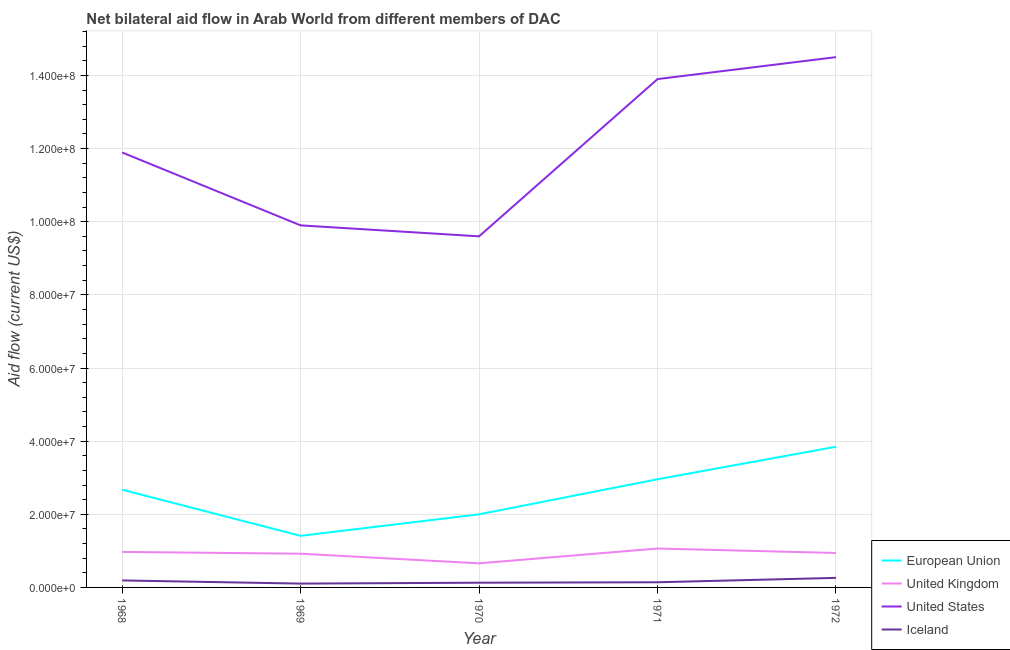How many different coloured lines are there?
Your answer should be compact. 4. What is the amount of aid given by us in 1971?
Make the answer very short. 1.39e+08. Across all years, what is the maximum amount of aid given by iceland?
Your response must be concise. 2.61e+06. Across all years, what is the minimum amount of aid given by eu?
Give a very brief answer. 1.41e+07. In which year was the amount of aid given by us maximum?
Your response must be concise. 1972. In which year was the amount of aid given by uk minimum?
Your answer should be compact. 1970. What is the total amount of aid given by iceland in the graph?
Your response must be concise. 8.27e+06. What is the difference between the amount of aid given by eu in 1971 and that in 1972?
Give a very brief answer. -8.89e+06. What is the difference between the amount of aid given by uk in 1970 and the amount of aid given by iceland in 1968?
Ensure brevity in your answer.  4.68e+06. What is the average amount of aid given by uk per year?
Your answer should be very brief. 9.12e+06. In the year 1968, what is the difference between the amount of aid given by us and amount of aid given by eu?
Your answer should be very brief. 9.22e+07. In how many years, is the amount of aid given by iceland greater than 120000000 US$?
Make the answer very short. 0. What is the ratio of the amount of aid given by us in 1969 to that in 1970?
Provide a succinct answer. 1.03. What is the difference between the highest and the lowest amount of aid given by uk?
Keep it short and to the point. 4.05e+06. Is it the case that in every year, the sum of the amount of aid given by iceland and amount of aid given by us is greater than the sum of amount of aid given by uk and amount of aid given by eu?
Your answer should be compact. Yes. Is it the case that in every year, the sum of the amount of aid given by eu and amount of aid given by uk is greater than the amount of aid given by us?
Your answer should be very brief. No. How many lines are there?
Your answer should be very brief. 4. How many years are there in the graph?
Give a very brief answer. 5. What is the difference between two consecutive major ticks on the Y-axis?
Your response must be concise. 2.00e+07. Are the values on the major ticks of Y-axis written in scientific E-notation?
Your answer should be very brief. Yes. Does the graph contain any zero values?
Ensure brevity in your answer.  No. How many legend labels are there?
Your answer should be very brief. 4. What is the title of the graph?
Your answer should be compact. Net bilateral aid flow in Arab World from different members of DAC. What is the label or title of the X-axis?
Give a very brief answer. Year. What is the Aid flow (current US$) of European Union in 1968?
Provide a short and direct response. 2.67e+07. What is the Aid flow (current US$) of United Kingdom in 1968?
Give a very brief answer. 9.71e+06. What is the Aid flow (current US$) of United States in 1968?
Offer a very short reply. 1.19e+08. What is the Aid flow (current US$) in Iceland in 1968?
Offer a very short reply. 1.91e+06. What is the Aid flow (current US$) in European Union in 1969?
Your answer should be very brief. 1.41e+07. What is the Aid flow (current US$) in United Kingdom in 1969?
Give a very brief answer. 9.22e+06. What is the Aid flow (current US$) of United States in 1969?
Keep it short and to the point. 9.90e+07. What is the Aid flow (current US$) in Iceland in 1969?
Offer a terse response. 1.05e+06. What is the Aid flow (current US$) in European Union in 1970?
Ensure brevity in your answer.  2.00e+07. What is the Aid flow (current US$) in United Kingdom in 1970?
Provide a short and direct response. 6.59e+06. What is the Aid flow (current US$) in United States in 1970?
Your answer should be compact. 9.60e+07. What is the Aid flow (current US$) of Iceland in 1970?
Make the answer very short. 1.29e+06. What is the Aid flow (current US$) in European Union in 1971?
Provide a short and direct response. 2.96e+07. What is the Aid flow (current US$) in United Kingdom in 1971?
Your response must be concise. 1.06e+07. What is the Aid flow (current US$) in United States in 1971?
Ensure brevity in your answer.  1.39e+08. What is the Aid flow (current US$) in Iceland in 1971?
Ensure brevity in your answer.  1.41e+06. What is the Aid flow (current US$) of European Union in 1972?
Offer a terse response. 3.85e+07. What is the Aid flow (current US$) of United Kingdom in 1972?
Your answer should be compact. 9.42e+06. What is the Aid flow (current US$) in United States in 1972?
Offer a terse response. 1.45e+08. What is the Aid flow (current US$) of Iceland in 1972?
Your answer should be compact. 2.61e+06. Across all years, what is the maximum Aid flow (current US$) of European Union?
Your answer should be very brief. 3.85e+07. Across all years, what is the maximum Aid flow (current US$) of United Kingdom?
Provide a succinct answer. 1.06e+07. Across all years, what is the maximum Aid flow (current US$) in United States?
Your answer should be very brief. 1.45e+08. Across all years, what is the maximum Aid flow (current US$) of Iceland?
Your answer should be compact. 2.61e+06. Across all years, what is the minimum Aid flow (current US$) of European Union?
Give a very brief answer. 1.41e+07. Across all years, what is the minimum Aid flow (current US$) of United Kingdom?
Ensure brevity in your answer.  6.59e+06. Across all years, what is the minimum Aid flow (current US$) in United States?
Your response must be concise. 9.60e+07. Across all years, what is the minimum Aid flow (current US$) of Iceland?
Make the answer very short. 1.05e+06. What is the total Aid flow (current US$) of European Union in the graph?
Offer a terse response. 1.29e+08. What is the total Aid flow (current US$) of United Kingdom in the graph?
Your answer should be very brief. 4.56e+07. What is the total Aid flow (current US$) of United States in the graph?
Ensure brevity in your answer.  5.98e+08. What is the total Aid flow (current US$) of Iceland in the graph?
Keep it short and to the point. 8.27e+06. What is the difference between the Aid flow (current US$) of European Union in 1968 and that in 1969?
Your answer should be very brief. 1.26e+07. What is the difference between the Aid flow (current US$) in United Kingdom in 1968 and that in 1969?
Provide a succinct answer. 4.90e+05. What is the difference between the Aid flow (current US$) of United States in 1968 and that in 1969?
Provide a short and direct response. 1.99e+07. What is the difference between the Aid flow (current US$) of Iceland in 1968 and that in 1969?
Ensure brevity in your answer.  8.60e+05. What is the difference between the Aid flow (current US$) in European Union in 1968 and that in 1970?
Make the answer very short. 6.73e+06. What is the difference between the Aid flow (current US$) in United Kingdom in 1968 and that in 1970?
Give a very brief answer. 3.12e+06. What is the difference between the Aid flow (current US$) in United States in 1968 and that in 1970?
Keep it short and to the point. 2.29e+07. What is the difference between the Aid flow (current US$) of Iceland in 1968 and that in 1970?
Your answer should be very brief. 6.20e+05. What is the difference between the Aid flow (current US$) in European Union in 1968 and that in 1971?
Offer a very short reply. -2.86e+06. What is the difference between the Aid flow (current US$) in United Kingdom in 1968 and that in 1971?
Provide a succinct answer. -9.30e+05. What is the difference between the Aid flow (current US$) in United States in 1968 and that in 1971?
Ensure brevity in your answer.  -2.01e+07. What is the difference between the Aid flow (current US$) in Iceland in 1968 and that in 1971?
Provide a short and direct response. 5.00e+05. What is the difference between the Aid flow (current US$) in European Union in 1968 and that in 1972?
Provide a succinct answer. -1.18e+07. What is the difference between the Aid flow (current US$) in United Kingdom in 1968 and that in 1972?
Provide a short and direct response. 2.90e+05. What is the difference between the Aid flow (current US$) in United States in 1968 and that in 1972?
Give a very brief answer. -2.61e+07. What is the difference between the Aid flow (current US$) of Iceland in 1968 and that in 1972?
Provide a short and direct response. -7.00e+05. What is the difference between the Aid flow (current US$) of European Union in 1969 and that in 1970?
Your response must be concise. -5.88e+06. What is the difference between the Aid flow (current US$) of United Kingdom in 1969 and that in 1970?
Ensure brevity in your answer.  2.63e+06. What is the difference between the Aid flow (current US$) of United States in 1969 and that in 1970?
Ensure brevity in your answer.  3.00e+06. What is the difference between the Aid flow (current US$) in Iceland in 1969 and that in 1970?
Your answer should be very brief. -2.40e+05. What is the difference between the Aid flow (current US$) of European Union in 1969 and that in 1971?
Offer a very short reply. -1.55e+07. What is the difference between the Aid flow (current US$) in United Kingdom in 1969 and that in 1971?
Keep it short and to the point. -1.42e+06. What is the difference between the Aid flow (current US$) of United States in 1969 and that in 1971?
Offer a terse response. -4.00e+07. What is the difference between the Aid flow (current US$) in Iceland in 1969 and that in 1971?
Provide a succinct answer. -3.60e+05. What is the difference between the Aid flow (current US$) in European Union in 1969 and that in 1972?
Keep it short and to the point. -2.44e+07. What is the difference between the Aid flow (current US$) in United Kingdom in 1969 and that in 1972?
Offer a very short reply. -2.00e+05. What is the difference between the Aid flow (current US$) of United States in 1969 and that in 1972?
Make the answer very short. -4.60e+07. What is the difference between the Aid flow (current US$) of Iceland in 1969 and that in 1972?
Provide a short and direct response. -1.56e+06. What is the difference between the Aid flow (current US$) in European Union in 1970 and that in 1971?
Offer a very short reply. -9.59e+06. What is the difference between the Aid flow (current US$) of United Kingdom in 1970 and that in 1971?
Make the answer very short. -4.05e+06. What is the difference between the Aid flow (current US$) in United States in 1970 and that in 1971?
Provide a succinct answer. -4.30e+07. What is the difference between the Aid flow (current US$) in Iceland in 1970 and that in 1971?
Your answer should be compact. -1.20e+05. What is the difference between the Aid flow (current US$) of European Union in 1970 and that in 1972?
Keep it short and to the point. -1.85e+07. What is the difference between the Aid flow (current US$) in United Kingdom in 1970 and that in 1972?
Ensure brevity in your answer.  -2.83e+06. What is the difference between the Aid flow (current US$) of United States in 1970 and that in 1972?
Offer a very short reply. -4.90e+07. What is the difference between the Aid flow (current US$) in Iceland in 1970 and that in 1972?
Keep it short and to the point. -1.32e+06. What is the difference between the Aid flow (current US$) of European Union in 1971 and that in 1972?
Provide a short and direct response. -8.89e+06. What is the difference between the Aid flow (current US$) of United Kingdom in 1971 and that in 1972?
Provide a succinct answer. 1.22e+06. What is the difference between the Aid flow (current US$) in United States in 1971 and that in 1972?
Your response must be concise. -6.00e+06. What is the difference between the Aid flow (current US$) in Iceland in 1971 and that in 1972?
Provide a short and direct response. -1.20e+06. What is the difference between the Aid flow (current US$) in European Union in 1968 and the Aid flow (current US$) in United Kingdom in 1969?
Your answer should be compact. 1.75e+07. What is the difference between the Aid flow (current US$) in European Union in 1968 and the Aid flow (current US$) in United States in 1969?
Offer a very short reply. -7.23e+07. What is the difference between the Aid flow (current US$) of European Union in 1968 and the Aid flow (current US$) of Iceland in 1969?
Your answer should be very brief. 2.57e+07. What is the difference between the Aid flow (current US$) of United Kingdom in 1968 and the Aid flow (current US$) of United States in 1969?
Keep it short and to the point. -8.93e+07. What is the difference between the Aid flow (current US$) of United Kingdom in 1968 and the Aid flow (current US$) of Iceland in 1969?
Keep it short and to the point. 8.66e+06. What is the difference between the Aid flow (current US$) in United States in 1968 and the Aid flow (current US$) in Iceland in 1969?
Make the answer very short. 1.18e+08. What is the difference between the Aid flow (current US$) in European Union in 1968 and the Aid flow (current US$) in United Kingdom in 1970?
Provide a succinct answer. 2.01e+07. What is the difference between the Aid flow (current US$) of European Union in 1968 and the Aid flow (current US$) of United States in 1970?
Your answer should be compact. -6.93e+07. What is the difference between the Aid flow (current US$) in European Union in 1968 and the Aid flow (current US$) in Iceland in 1970?
Ensure brevity in your answer.  2.54e+07. What is the difference between the Aid flow (current US$) in United Kingdom in 1968 and the Aid flow (current US$) in United States in 1970?
Make the answer very short. -8.63e+07. What is the difference between the Aid flow (current US$) in United Kingdom in 1968 and the Aid flow (current US$) in Iceland in 1970?
Offer a very short reply. 8.42e+06. What is the difference between the Aid flow (current US$) of United States in 1968 and the Aid flow (current US$) of Iceland in 1970?
Make the answer very short. 1.18e+08. What is the difference between the Aid flow (current US$) of European Union in 1968 and the Aid flow (current US$) of United Kingdom in 1971?
Keep it short and to the point. 1.61e+07. What is the difference between the Aid flow (current US$) in European Union in 1968 and the Aid flow (current US$) in United States in 1971?
Your answer should be very brief. -1.12e+08. What is the difference between the Aid flow (current US$) in European Union in 1968 and the Aid flow (current US$) in Iceland in 1971?
Ensure brevity in your answer.  2.53e+07. What is the difference between the Aid flow (current US$) of United Kingdom in 1968 and the Aid flow (current US$) of United States in 1971?
Provide a succinct answer. -1.29e+08. What is the difference between the Aid flow (current US$) in United Kingdom in 1968 and the Aid flow (current US$) in Iceland in 1971?
Offer a terse response. 8.30e+06. What is the difference between the Aid flow (current US$) in United States in 1968 and the Aid flow (current US$) in Iceland in 1971?
Your answer should be very brief. 1.18e+08. What is the difference between the Aid flow (current US$) in European Union in 1968 and the Aid flow (current US$) in United Kingdom in 1972?
Offer a terse response. 1.73e+07. What is the difference between the Aid flow (current US$) in European Union in 1968 and the Aid flow (current US$) in United States in 1972?
Offer a terse response. -1.18e+08. What is the difference between the Aid flow (current US$) of European Union in 1968 and the Aid flow (current US$) of Iceland in 1972?
Ensure brevity in your answer.  2.41e+07. What is the difference between the Aid flow (current US$) of United Kingdom in 1968 and the Aid flow (current US$) of United States in 1972?
Provide a succinct answer. -1.35e+08. What is the difference between the Aid flow (current US$) in United Kingdom in 1968 and the Aid flow (current US$) in Iceland in 1972?
Offer a terse response. 7.10e+06. What is the difference between the Aid flow (current US$) in United States in 1968 and the Aid flow (current US$) in Iceland in 1972?
Give a very brief answer. 1.16e+08. What is the difference between the Aid flow (current US$) in European Union in 1969 and the Aid flow (current US$) in United Kingdom in 1970?
Ensure brevity in your answer.  7.52e+06. What is the difference between the Aid flow (current US$) in European Union in 1969 and the Aid flow (current US$) in United States in 1970?
Keep it short and to the point. -8.19e+07. What is the difference between the Aid flow (current US$) of European Union in 1969 and the Aid flow (current US$) of Iceland in 1970?
Your answer should be very brief. 1.28e+07. What is the difference between the Aid flow (current US$) in United Kingdom in 1969 and the Aid flow (current US$) in United States in 1970?
Provide a succinct answer. -8.68e+07. What is the difference between the Aid flow (current US$) of United Kingdom in 1969 and the Aid flow (current US$) of Iceland in 1970?
Your answer should be compact. 7.93e+06. What is the difference between the Aid flow (current US$) of United States in 1969 and the Aid flow (current US$) of Iceland in 1970?
Keep it short and to the point. 9.77e+07. What is the difference between the Aid flow (current US$) of European Union in 1969 and the Aid flow (current US$) of United Kingdom in 1971?
Your answer should be very brief. 3.47e+06. What is the difference between the Aid flow (current US$) in European Union in 1969 and the Aid flow (current US$) in United States in 1971?
Make the answer very short. -1.25e+08. What is the difference between the Aid flow (current US$) of European Union in 1969 and the Aid flow (current US$) of Iceland in 1971?
Your answer should be compact. 1.27e+07. What is the difference between the Aid flow (current US$) of United Kingdom in 1969 and the Aid flow (current US$) of United States in 1971?
Provide a succinct answer. -1.30e+08. What is the difference between the Aid flow (current US$) in United Kingdom in 1969 and the Aid flow (current US$) in Iceland in 1971?
Offer a terse response. 7.81e+06. What is the difference between the Aid flow (current US$) in United States in 1969 and the Aid flow (current US$) in Iceland in 1971?
Provide a short and direct response. 9.76e+07. What is the difference between the Aid flow (current US$) in European Union in 1969 and the Aid flow (current US$) in United Kingdom in 1972?
Make the answer very short. 4.69e+06. What is the difference between the Aid flow (current US$) of European Union in 1969 and the Aid flow (current US$) of United States in 1972?
Keep it short and to the point. -1.31e+08. What is the difference between the Aid flow (current US$) of European Union in 1969 and the Aid flow (current US$) of Iceland in 1972?
Your answer should be compact. 1.15e+07. What is the difference between the Aid flow (current US$) in United Kingdom in 1969 and the Aid flow (current US$) in United States in 1972?
Keep it short and to the point. -1.36e+08. What is the difference between the Aid flow (current US$) in United Kingdom in 1969 and the Aid flow (current US$) in Iceland in 1972?
Provide a succinct answer. 6.61e+06. What is the difference between the Aid flow (current US$) of United States in 1969 and the Aid flow (current US$) of Iceland in 1972?
Ensure brevity in your answer.  9.64e+07. What is the difference between the Aid flow (current US$) of European Union in 1970 and the Aid flow (current US$) of United Kingdom in 1971?
Ensure brevity in your answer.  9.35e+06. What is the difference between the Aid flow (current US$) of European Union in 1970 and the Aid flow (current US$) of United States in 1971?
Your answer should be very brief. -1.19e+08. What is the difference between the Aid flow (current US$) of European Union in 1970 and the Aid flow (current US$) of Iceland in 1971?
Ensure brevity in your answer.  1.86e+07. What is the difference between the Aid flow (current US$) of United Kingdom in 1970 and the Aid flow (current US$) of United States in 1971?
Give a very brief answer. -1.32e+08. What is the difference between the Aid flow (current US$) in United Kingdom in 1970 and the Aid flow (current US$) in Iceland in 1971?
Your answer should be compact. 5.18e+06. What is the difference between the Aid flow (current US$) in United States in 1970 and the Aid flow (current US$) in Iceland in 1971?
Give a very brief answer. 9.46e+07. What is the difference between the Aid flow (current US$) in European Union in 1970 and the Aid flow (current US$) in United Kingdom in 1972?
Your answer should be compact. 1.06e+07. What is the difference between the Aid flow (current US$) of European Union in 1970 and the Aid flow (current US$) of United States in 1972?
Provide a short and direct response. -1.25e+08. What is the difference between the Aid flow (current US$) of European Union in 1970 and the Aid flow (current US$) of Iceland in 1972?
Ensure brevity in your answer.  1.74e+07. What is the difference between the Aid flow (current US$) of United Kingdom in 1970 and the Aid flow (current US$) of United States in 1972?
Provide a short and direct response. -1.38e+08. What is the difference between the Aid flow (current US$) of United Kingdom in 1970 and the Aid flow (current US$) of Iceland in 1972?
Provide a short and direct response. 3.98e+06. What is the difference between the Aid flow (current US$) of United States in 1970 and the Aid flow (current US$) of Iceland in 1972?
Ensure brevity in your answer.  9.34e+07. What is the difference between the Aid flow (current US$) in European Union in 1971 and the Aid flow (current US$) in United Kingdom in 1972?
Your answer should be very brief. 2.02e+07. What is the difference between the Aid flow (current US$) of European Union in 1971 and the Aid flow (current US$) of United States in 1972?
Offer a terse response. -1.15e+08. What is the difference between the Aid flow (current US$) in European Union in 1971 and the Aid flow (current US$) in Iceland in 1972?
Offer a very short reply. 2.70e+07. What is the difference between the Aid flow (current US$) of United Kingdom in 1971 and the Aid flow (current US$) of United States in 1972?
Your answer should be very brief. -1.34e+08. What is the difference between the Aid flow (current US$) in United Kingdom in 1971 and the Aid flow (current US$) in Iceland in 1972?
Provide a succinct answer. 8.03e+06. What is the difference between the Aid flow (current US$) of United States in 1971 and the Aid flow (current US$) of Iceland in 1972?
Offer a terse response. 1.36e+08. What is the average Aid flow (current US$) of European Union per year?
Provide a short and direct response. 2.58e+07. What is the average Aid flow (current US$) in United Kingdom per year?
Provide a succinct answer. 9.12e+06. What is the average Aid flow (current US$) in United States per year?
Keep it short and to the point. 1.20e+08. What is the average Aid flow (current US$) in Iceland per year?
Offer a terse response. 1.65e+06. In the year 1968, what is the difference between the Aid flow (current US$) of European Union and Aid flow (current US$) of United Kingdom?
Keep it short and to the point. 1.70e+07. In the year 1968, what is the difference between the Aid flow (current US$) of European Union and Aid flow (current US$) of United States?
Make the answer very short. -9.22e+07. In the year 1968, what is the difference between the Aid flow (current US$) of European Union and Aid flow (current US$) of Iceland?
Provide a short and direct response. 2.48e+07. In the year 1968, what is the difference between the Aid flow (current US$) of United Kingdom and Aid flow (current US$) of United States?
Offer a very short reply. -1.09e+08. In the year 1968, what is the difference between the Aid flow (current US$) of United Kingdom and Aid flow (current US$) of Iceland?
Make the answer very short. 7.80e+06. In the year 1968, what is the difference between the Aid flow (current US$) of United States and Aid flow (current US$) of Iceland?
Your answer should be compact. 1.17e+08. In the year 1969, what is the difference between the Aid flow (current US$) in European Union and Aid flow (current US$) in United Kingdom?
Keep it short and to the point. 4.89e+06. In the year 1969, what is the difference between the Aid flow (current US$) in European Union and Aid flow (current US$) in United States?
Provide a succinct answer. -8.49e+07. In the year 1969, what is the difference between the Aid flow (current US$) in European Union and Aid flow (current US$) in Iceland?
Provide a succinct answer. 1.31e+07. In the year 1969, what is the difference between the Aid flow (current US$) in United Kingdom and Aid flow (current US$) in United States?
Give a very brief answer. -8.98e+07. In the year 1969, what is the difference between the Aid flow (current US$) of United Kingdom and Aid flow (current US$) of Iceland?
Your answer should be compact. 8.17e+06. In the year 1969, what is the difference between the Aid flow (current US$) of United States and Aid flow (current US$) of Iceland?
Make the answer very short. 9.80e+07. In the year 1970, what is the difference between the Aid flow (current US$) of European Union and Aid flow (current US$) of United Kingdom?
Keep it short and to the point. 1.34e+07. In the year 1970, what is the difference between the Aid flow (current US$) in European Union and Aid flow (current US$) in United States?
Provide a short and direct response. -7.60e+07. In the year 1970, what is the difference between the Aid flow (current US$) of European Union and Aid flow (current US$) of Iceland?
Your answer should be compact. 1.87e+07. In the year 1970, what is the difference between the Aid flow (current US$) of United Kingdom and Aid flow (current US$) of United States?
Provide a short and direct response. -8.94e+07. In the year 1970, what is the difference between the Aid flow (current US$) of United Kingdom and Aid flow (current US$) of Iceland?
Provide a short and direct response. 5.30e+06. In the year 1970, what is the difference between the Aid flow (current US$) in United States and Aid flow (current US$) in Iceland?
Provide a short and direct response. 9.47e+07. In the year 1971, what is the difference between the Aid flow (current US$) of European Union and Aid flow (current US$) of United Kingdom?
Keep it short and to the point. 1.89e+07. In the year 1971, what is the difference between the Aid flow (current US$) of European Union and Aid flow (current US$) of United States?
Offer a terse response. -1.09e+08. In the year 1971, what is the difference between the Aid flow (current US$) of European Union and Aid flow (current US$) of Iceland?
Your answer should be very brief. 2.82e+07. In the year 1971, what is the difference between the Aid flow (current US$) in United Kingdom and Aid flow (current US$) in United States?
Your answer should be very brief. -1.28e+08. In the year 1971, what is the difference between the Aid flow (current US$) of United Kingdom and Aid flow (current US$) of Iceland?
Keep it short and to the point. 9.23e+06. In the year 1971, what is the difference between the Aid flow (current US$) of United States and Aid flow (current US$) of Iceland?
Your answer should be compact. 1.38e+08. In the year 1972, what is the difference between the Aid flow (current US$) in European Union and Aid flow (current US$) in United Kingdom?
Make the answer very short. 2.90e+07. In the year 1972, what is the difference between the Aid flow (current US$) in European Union and Aid flow (current US$) in United States?
Offer a very short reply. -1.07e+08. In the year 1972, what is the difference between the Aid flow (current US$) of European Union and Aid flow (current US$) of Iceland?
Ensure brevity in your answer.  3.59e+07. In the year 1972, what is the difference between the Aid flow (current US$) in United Kingdom and Aid flow (current US$) in United States?
Provide a short and direct response. -1.36e+08. In the year 1972, what is the difference between the Aid flow (current US$) in United Kingdom and Aid flow (current US$) in Iceland?
Your answer should be compact. 6.81e+06. In the year 1972, what is the difference between the Aid flow (current US$) in United States and Aid flow (current US$) in Iceland?
Ensure brevity in your answer.  1.42e+08. What is the ratio of the Aid flow (current US$) of European Union in 1968 to that in 1969?
Provide a short and direct response. 1.89. What is the ratio of the Aid flow (current US$) in United Kingdom in 1968 to that in 1969?
Keep it short and to the point. 1.05. What is the ratio of the Aid flow (current US$) of United States in 1968 to that in 1969?
Offer a terse response. 1.2. What is the ratio of the Aid flow (current US$) in Iceland in 1968 to that in 1969?
Offer a very short reply. 1.82. What is the ratio of the Aid flow (current US$) in European Union in 1968 to that in 1970?
Your response must be concise. 1.34. What is the ratio of the Aid flow (current US$) of United Kingdom in 1968 to that in 1970?
Ensure brevity in your answer.  1.47. What is the ratio of the Aid flow (current US$) in United States in 1968 to that in 1970?
Your response must be concise. 1.24. What is the ratio of the Aid flow (current US$) of Iceland in 1968 to that in 1970?
Ensure brevity in your answer.  1.48. What is the ratio of the Aid flow (current US$) of European Union in 1968 to that in 1971?
Offer a very short reply. 0.9. What is the ratio of the Aid flow (current US$) in United Kingdom in 1968 to that in 1971?
Your response must be concise. 0.91. What is the ratio of the Aid flow (current US$) in United States in 1968 to that in 1971?
Provide a short and direct response. 0.86. What is the ratio of the Aid flow (current US$) of Iceland in 1968 to that in 1971?
Keep it short and to the point. 1.35. What is the ratio of the Aid flow (current US$) of European Union in 1968 to that in 1972?
Your response must be concise. 0.69. What is the ratio of the Aid flow (current US$) in United Kingdom in 1968 to that in 1972?
Your response must be concise. 1.03. What is the ratio of the Aid flow (current US$) of United States in 1968 to that in 1972?
Ensure brevity in your answer.  0.82. What is the ratio of the Aid flow (current US$) in Iceland in 1968 to that in 1972?
Ensure brevity in your answer.  0.73. What is the ratio of the Aid flow (current US$) of European Union in 1969 to that in 1970?
Give a very brief answer. 0.71. What is the ratio of the Aid flow (current US$) in United Kingdom in 1969 to that in 1970?
Your answer should be compact. 1.4. What is the ratio of the Aid flow (current US$) of United States in 1969 to that in 1970?
Make the answer very short. 1.03. What is the ratio of the Aid flow (current US$) of Iceland in 1969 to that in 1970?
Offer a very short reply. 0.81. What is the ratio of the Aid flow (current US$) of European Union in 1969 to that in 1971?
Make the answer very short. 0.48. What is the ratio of the Aid flow (current US$) of United Kingdom in 1969 to that in 1971?
Provide a succinct answer. 0.87. What is the ratio of the Aid flow (current US$) in United States in 1969 to that in 1971?
Give a very brief answer. 0.71. What is the ratio of the Aid flow (current US$) in Iceland in 1969 to that in 1971?
Ensure brevity in your answer.  0.74. What is the ratio of the Aid flow (current US$) of European Union in 1969 to that in 1972?
Provide a succinct answer. 0.37. What is the ratio of the Aid flow (current US$) in United Kingdom in 1969 to that in 1972?
Offer a very short reply. 0.98. What is the ratio of the Aid flow (current US$) in United States in 1969 to that in 1972?
Provide a succinct answer. 0.68. What is the ratio of the Aid flow (current US$) of Iceland in 1969 to that in 1972?
Your response must be concise. 0.4. What is the ratio of the Aid flow (current US$) in European Union in 1970 to that in 1971?
Give a very brief answer. 0.68. What is the ratio of the Aid flow (current US$) in United Kingdom in 1970 to that in 1971?
Your response must be concise. 0.62. What is the ratio of the Aid flow (current US$) of United States in 1970 to that in 1971?
Ensure brevity in your answer.  0.69. What is the ratio of the Aid flow (current US$) in Iceland in 1970 to that in 1971?
Make the answer very short. 0.91. What is the ratio of the Aid flow (current US$) of European Union in 1970 to that in 1972?
Keep it short and to the point. 0.52. What is the ratio of the Aid flow (current US$) in United Kingdom in 1970 to that in 1972?
Provide a succinct answer. 0.7. What is the ratio of the Aid flow (current US$) in United States in 1970 to that in 1972?
Offer a very short reply. 0.66. What is the ratio of the Aid flow (current US$) of Iceland in 1970 to that in 1972?
Your answer should be very brief. 0.49. What is the ratio of the Aid flow (current US$) of European Union in 1971 to that in 1972?
Your answer should be compact. 0.77. What is the ratio of the Aid flow (current US$) of United Kingdom in 1971 to that in 1972?
Your response must be concise. 1.13. What is the ratio of the Aid flow (current US$) in United States in 1971 to that in 1972?
Give a very brief answer. 0.96. What is the ratio of the Aid flow (current US$) of Iceland in 1971 to that in 1972?
Your answer should be very brief. 0.54. What is the difference between the highest and the second highest Aid flow (current US$) in European Union?
Offer a very short reply. 8.89e+06. What is the difference between the highest and the second highest Aid flow (current US$) of United Kingdom?
Provide a succinct answer. 9.30e+05. What is the difference between the highest and the second highest Aid flow (current US$) of United States?
Keep it short and to the point. 6.00e+06. What is the difference between the highest and the lowest Aid flow (current US$) in European Union?
Ensure brevity in your answer.  2.44e+07. What is the difference between the highest and the lowest Aid flow (current US$) of United Kingdom?
Keep it short and to the point. 4.05e+06. What is the difference between the highest and the lowest Aid flow (current US$) of United States?
Offer a terse response. 4.90e+07. What is the difference between the highest and the lowest Aid flow (current US$) in Iceland?
Make the answer very short. 1.56e+06. 